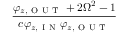Convert formula to latex. <formula><loc_0><loc_0><loc_500><loc_500>\frac { \varphi _ { z , O U T } + 2 \Omega ^ { 2 } - 1 } { c \varphi _ { z , I N } \varphi _ { z , O U T } }</formula> 